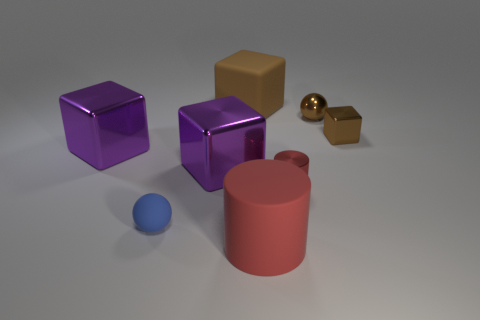There is another block that is the same color as the tiny metal cube; what is its material? The block that is the same color as the tiny metal cube appears to be made of the same polished metal but in a larger size. 